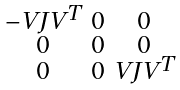Convert formula to latex. <formula><loc_0><loc_0><loc_500><loc_500>\begin{smallmatrix} - V J V ^ { T } & 0 & 0 \\ 0 & 0 & 0 \\ 0 & 0 & V J V ^ { T } \end{smallmatrix}</formula> 